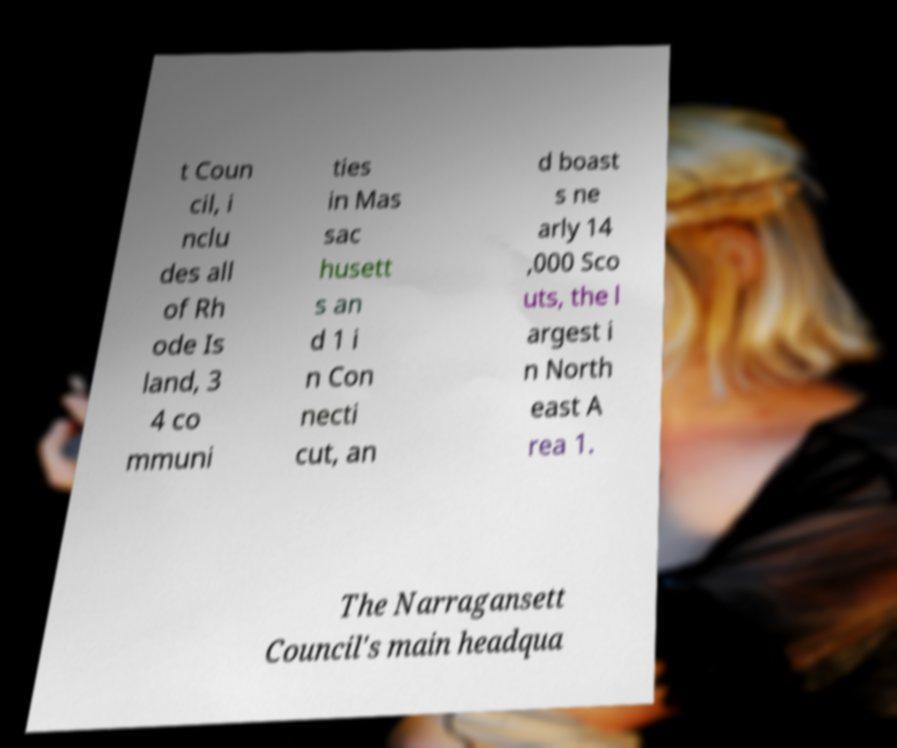Could you extract and type out the text from this image? t Coun cil, i nclu des all of Rh ode Is land, 3 4 co mmuni ties in Mas sac husett s an d 1 i n Con necti cut, an d boast s ne arly 14 ,000 Sco uts, the l argest i n North east A rea 1. The Narragansett Council's main headqua 